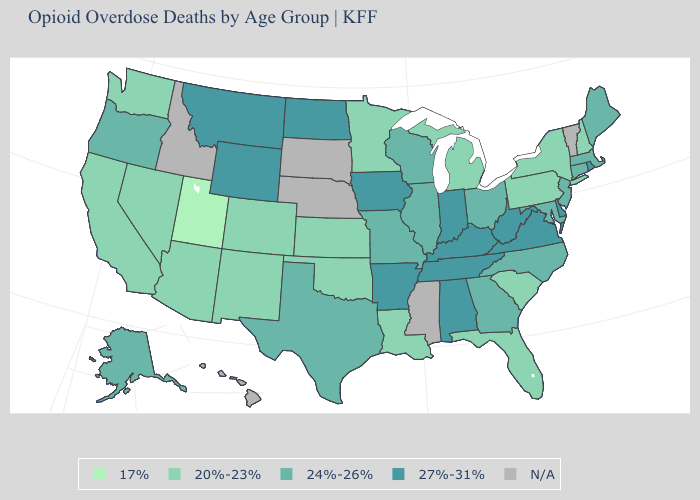Does the first symbol in the legend represent the smallest category?
Short answer required. Yes. Name the states that have a value in the range 24%-26%?
Write a very short answer. Alaska, Connecticut, Georgia, Illinois, Maine, Maryland, Massachusetts, Missouri, New Jersey, North Carolina, Ohio, Oregon, Texas, Wisconsin. Among the states that border Delaware , which have the lowest value?
Keep it brief. Pennsylvania. Name the states that have a value in the range 17%?
Write a very short answer. Utah. What is the lowest value in states that border Minnesota?
Be succinct. 24%-26%. What is the value of Georgia?
Quick response, please. 24%-26%. Which states have the highest value in the USA?
Quick response, please. Alabama, Arkansas, Delaware, Indiana, Iowa, Kentucky, Montana, North Dakota, Rhode Island, Tennessee, Virginia, West Virginia, Wyoming. Does the map have missing data?
Concise answer only. Yes. Among the states that border New Jersey , does Delaware have the highest value?
Concise answer only. Yes. Does Wyoming have the highest value in the USA?
Give a very brief answer. Yes. Among the states that border South Carolina , which have the highest value?
Write a very short answer. Georgia, North Carolina. What is the lowest value in the West?
Be succinct. 17%. Name the states that have a value in the range 20%-23%?
Concise answer only. Arizona, California, Colorado, Florida, Kansas, Louisiana, Michigan, Minnesota, Nevada, New Hampshire, New Mexico, New York, Oklahoma, Pennsylvania, South Carolina, Washington. 